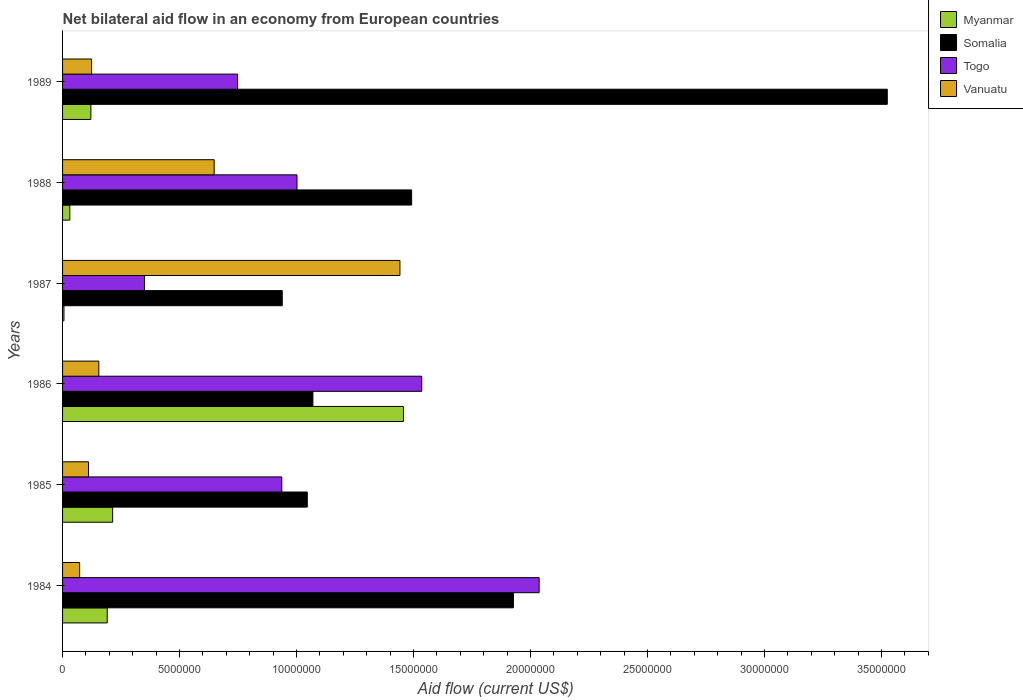How many different coloured bars are there?
Provide a succinct answer. 4. How many bars are there on the 1st tick from the top?
Your answer should be compact. 4. How many bars are there on the 5th tick from the bottom?
Your response must be concise. 4. In how many cases, is the number of bars for a given year not equal to the number of legend labels?
Keep it short and to the point. 0. What is the net bilateral aid flow in Myanmar in 1985?
Ensure brevity in your answer.  2.14e+06. Across all years, what is the maximum net bilateral aid flow in Vanuatu?
Keep it short and to the point. 1.44e+07. In which year was the net bilateral aid flow in Togo minimum?
Offer a terse response. 1987. What is the total net bilateral aid flow in Togo in the graph?
Give a very brief answer. 6.61e+07. What is the difference between the net bilateral aid flow in Vanuatu in 1985 and the net bilateral aid flow in Somalia in 1989?
Make the answer very short. -3.41e+07. What is the average net bilateral aid flow in Togo per year?
Provide a short and direct response. 1.10e+07. In how many years, is the net bilateral aid flow in Somalia greater than 17000000 US$?
Ensure brevity in your answer.  2. What is the ratio of the net bilateral aid flow in Togo in 1987 to that in 1989?
Keep it short and to the point. 0.47. Is the net bilateral aid flow in Togo in 1984 less than that in 1989?
Offer a very short reply. No. What is the difference between the highest and the second highest net bilateral aid flow in Myanmar?
Offer a terse response. 1.24e+07. What is the difference between the highest and the lowest net bilateral aid flow in Myanmar?
Your answer should be very brief. 1.45e+07. Is it the case that in every year, the sum of the net bilateral aid flow in Togo and net bilateral aid flow in Vanuatu is greater than the sum of net bilateral aid flow in Myanmar and net bilateral aid flow in Somalia?
Provide a short and direct response. No. What does the 2nd bar from the top in 1989 represents?
Provide a short and direct response. Togo. What does the 4th bar from the bottom in 1986 represents?
Provide a short and direct response. Vanuatu. Is it the case that in every year, the sum of the net bilateral aid flow in Vanuatu and net bilateral aid flow in Togo is greater than the net bilateral aid flow in Somalia?
Provide a short and direct response. No. How many bars are there?
Provide a short and direct response. 24. What is the difference between two consecutive major ticks on the X-axis?
Keep it short and to the point. 5.00e+06. Does the graph contain grids?
Your answer should be compact. No. Where does the legend appear in the graph?
Your answer should be very brief. Top right. What is the title of the graph?
Your answer should be compact. Net bilateral aid flow in an economy from European countries. Does "Mali" appear as one of the legend labels in the graph?
Give a very brief answer. No. What is the label or title of the Y-axis?
Ensure brevity in your answer.  Years. What is the Aid flow (current US$) of Myanmar in 1984?
Offer a terse response. 1.91e+06. What is the Aid flow (current US$) of Somalia in 1984?
Ensure brevity in your answer.  1.93e+07. What is the Aid flow (current US$) in Togo in 1984?
Your answer should be compact. 2.04e+07. What is the Aid flow (current US$) of Vanuatu in 1984?
Provide a succinct answer. 7.30e+05. What is the Aid flow (current US$) of Myanmar in 1985?
Make the answer very short. 2.14e+06. What is the Aid flow (current US$) of Somalia in 1985?
Provide a short and direct response. 1.05e+07. What is the Aid flow (current US$) of Togo in 1985?
Keep it short and to the point. 9.37e+06. What is the Aid flow (current US$) of Vanuatu in 1985?
Keep it short and to the point. 1.11e+06. What is the Aid flow (current US$) in Myanmar in 1986?
Offer a terse response. 1.46e+07. What is the Aid flow (current US$) in Somalia in 1986?
Your answer should be very brief. 1.07e+07. What is the Aid flow (current US$) in Togo in 1986?
Provide a succinct answer. 1.54e+07. What is the Aid flow (current US$) of Vanuatu in 1986?
Ensure brevity in your answer.  1.55e+06. What is the Aid flow (current US$) of Somalia in 1987?
Keep it short and to the point. 9.39e+06. What is the Aid flow (current US$) of Togo in 1987?
Provide a short and direct response. 3.50e+06. What is the Aid flow (current US$) in Vanuatu in 1987?
Make the answer very short. 1.44e+07. What is the Aid flow (current US$) in Somalia in 1988?
Your answer should be very brief. 1.49e+07. What is the Aid flow (current US$) in Togo in 1988?
Make the answer very short. 1.00e+07. What is the Aid flow (current US$) of Vanuatu in 1988?
Your answer should be compact. 6.48e+06. What is the Aid flow (current US$) of Myanmar in 1989?
Give a very brief answer. 1.21e+06. What is the Aid flow (current US$) of Somalia in 1989?
Offer a very short reply. 3.52e+07. What is the Aid flow (current US$) of Togo in 1989?
Give a very brief answer. 7.48e+06. What is the Aid flow (current US$) of Vanuatu in 1989?
Offer a terse response. 1.24e+06. Across all years, what is the maximum Aid flow (current US$) in Myanmar?
Offer a terse response. 1.46e+07. Across all years, what is the maximum Aid flow (current US$) of Somalia?
Offer a terse response. 3.52e+07. Across all years, what is the maximum Aid flow (current US$) of Togo?
Make the answer very short. 2.04e+07. Across all years, what is the maximum Aid flow (current US$) of Vanuatu?
Offer a very short reply. 1.44e+07. Across all years, what is the minimum Aid flow (current US$) of Myanmar?
Provide a short and direct response. 6.00e+04. Across all years, what is the minimum Aid flow (current US$) in Somalia?
Offer a terse response. 9.39e+06. Across all years, what is the minimum Aid flow (current US$) of Togo?
Give a very brief answer. 3.50e+06. Across all years, what is the minimum Aid flow (current US$) of Vanuatu?
Make the answer very short. 7.30e+05. What is the total Aid flow (current US$) in Myanmar in the graph?
Your response must be concise. 2.02e+07. What is the total Aid flow (current US$) in Somalia in the graph?
Offer a very short reply. 1.00e+08. What is the total Aid flow (current US$) of Togo in the graph?
Your answer should be very brief. 6.61e+07. What is the total Aid flow (current US$) of Vanuatu in the graph?
Make the answer very short. 2.55e+07. What is the difference between the Aid flow (current US$) of Somalia in 1984 and that in 1985?
Keep it short and to the point. 8.81e+06. What is the difference between the Aid flow (current US$) in Togo in 1984 and that in 1985?
Offer a terse response. 1.10e+07. What is the difference between the Aid flow (current US$) in Vanuatu in 1984 and that in 1985?
Offer a very short reply. -3.80e+05. What is the difference between the Aid flow (current US$) in Myanmar in 1984 and that in 1986?
Give a very brief answer. -1.27e+07. What is the difference between the Aid flow (current US$) in Somalia in 1984 and that in 1986?
Provide a succinct answer. 8.57e+06. What is the difference between the Aid flow (current US$) in Togo in 1984 and that in 1986?
Provide a short and direct response. 5.02e+06. What is the difference between the Aid flow (current US$) in Vanuatu in 1984 and that in 1986?
Your answer should be very brief. -8.20e+05. What is the difference between the Aid flow (current US$) in Myanmar in 1984 and that in 1987?
Offer a very short reply. 1.85e+06. What is the difference between the Aid flow (current US$) in Somalia in 1984 and that in 1987?
Offer a very short reply. 9.88e+06. What is the difference between the Aid flow (current US$) of Togo in 1984 and that in 1987?
Your answer should be very brief. 1.69e+07. What is the difference between the Aid flow (current US$) in Vanuatu in 1984 and that in 1987?
Keep it short and to the point. -1.37e+07. What is the difference between the Aid flow (current US$) of Myanmar in 1984 and that in 1988?
Keep it short and to the point. 1.60e+06. What is the difference between the Aid flow (current US$) in Somalia in 1984 and that in 1988?
Offer a terse response. 4.35e+06. What is the difference between the Aid flow (current US$) of Togo in 1984 and that in 1988?
Offer a terse response. 1.04e+07. What is the difference between the Aid flow (current US$) in Vanuatu in 1984 and that in 1988?
Make the answer very short. -5.75e+06. What is the difference between the Aid flow (current US$) in Myanmar in 1984 and that in 1989?
Provide a succinct answer. 7.00e+05. What is the difference between the Aid flow (current US$) of Somalia in 1984 and that in 1989?
Provide a short and direct response. -1.60e+07. What is the difference between the Aid flow (current US$) of Togo in 1984 and that in 1989?
Give a very brief answer. 1.29e+07. What is the difference between the Aid flow (current US$) of Vanuatu in 1984 and that in 1989?
Make the answer very short. -5.10e+05. What is the difference between the Aid flow (current US$) of Myanmar in 1985 and that in 1986?
Your response must be concise. -1.24e+07. What is the difference between the Aid flow (current US$) of Togo in 1985 and that in 1986?
Make the answer very short. -5.98e+06. What is the difference between the Aid flow (current US$) of Vanuatu in 1985 and that in 1986?
Make the answer very short. -4.40e+05. What is the difference between the Aid flow (current US$) in Myanmar in 1985 and that in 1987?
Your answer should be very brief. 2.08e+06. What is the difference between the Aid flow (current US$) of Somalia in 1985 and that in 1987?
Give a very brief answer. 1.07e+06. What is the difference between the Aid flow (current US$) of Togo in 1985 and that in 1987?
Provide a succinct answer. 5.87e+06. What is the difference between the Aid flow (current US$) of Vanuatu in 1985 and that in 1987?
Offer a terse response. -1.33e+07. What is the difference between the Aid flow (current US$) of Myanmar in 1985 and that in 1988?
Ensure brevity in your answer.  1.83e+06. What is the difference between the Aid flow (current US$) of Somalia in 1985 and that in 1988?
Your answer should be very brief. -4.46e+06. What is the difference between the Aid flow (current US$) in Togo in 1985 and that in 1988?
Your answer should be compact. -6.50e+05. What is the difference between the Aid flow (current US$) in Vanuatu in 1985 and that in 1988?
Make the answer very short. -5.37e+06. What is the difference between the Aid flow (current US$) of Myanmar in 1985 and that in 1989?
Offer a terse response. 9.30e+05. What is the difference between the Aid flow (current US$) in Somalia in 1985 and that in 1989?
Your response must be concise. -2.48e+07. What is the difference between the Aid flow (current US$) in Togo in 1985 and that in 1989?
Provide a succinct answer. 1.89e+06. What is the difference between the Aid flow (current US$) of Myanmar in 1986 and that in 1987?
Provide a short and direct response. 1.45e+07. What is the difference between the Aid flow (current US$) of Somalia in 1986 and that in 1987?
Your answer should be compact. 1.31e+06. What is the difference between the Aid flow (current US$) in Togo in 1986 and that in 1987?
Ensure brevity in your answer.  1.18e+07. What is the difference between the Aid flow (current US$) in Vanuatu in 1986 and that in 1987?
Provide a succinct answer. -1.29e+07. What is the difference between the Aid flow (current US$) of Myanmar in 1986 and that in 1988?
Keep it short and to the point. 1.43e+07. What is the difference between the Aid flow (current US$) of Somalia in 1986 and that in 1988?
Provide a succinct answer. -4.22e+06. What is the difference between the Aid flow (current US$) of Togo in 1986 and that in 1988?
Your response must be concise. 5.33e+06. What is the difference between the Aid flow (current US$) of Vanuatu in 1986 and that in 1988?
Offer a terse response. -4.93e+06. What is the difference between the Aid flow (current US$) of Myanmar in 1986 and that in 1989?
Offer a terse response. 1.34e+07. What is the difference between the Aid flow (current US$) in Somalia in 1986 and that in 1989?
Your response must be concise. -2.46e+07. What is the difference between the Aid flow (current US$) in Togo in 1986 and that in 1989?
Ensure brevity in your answer.  7.87e+06. What is the difference between the Aid flow (current US$) in Somalia in 1987 and that in 1988?
Make the answer very short. -5.53e+06. What is the difference between the Aid flow (current US$) of Togo in 1987 and that in 1988?
Provide a succinct answer. -6.52e+06. What is the difference between the Aid flow (current US$) in Vanuatu in 1987 and that in 1988?
Your answer should be very brief. 7.94e+06. What is the difference between the Aid flow (current US$) of Myanmar in 1987 and that in 1989?
Provide a short and direct response. -1.15e+06. What is the difference between the Aid flow (current US$) in Somalia in 1987 and that in 1989?
Your answer should be compact. -2.59e+07. What is the difference between the Aid flow (current US$) of Togo in 1987 and that in 1989?
Your answer should be compact. -3.98e+06. What is the difference between the Aid flow (current US$) in Vanuatu in 1987 and that in 1989?
Offer a very short reply. 1.32e+07. What is the difference between the Aid flow (current US$) in Myanmar in 1988 and that in 1989?
Give a very brief answer. -9.00e+05. What is the difference between the Aid flow (current US$) in Somalia in 1988 and that in 1989?
Offer a very short reply. -2.03e+07. What is the difference between the Aid flow (current US$) in Togo in 1988 and that in 1989?
Your response must be concise. 2.54e+06. What is the difference between the Aid flow (current US$) of Vanuatu in 1988 and that in 1989?
Make the answer very short. 5.24e+06. What is the difference between the Aid flow (current US$) in Myanmar in 1984 and the Aid flow (current US$) in Somalia in 1985?
Give a very brief answer. -8.55e+06. What is the difference between the Aid flow (current US$) in Myanmar in 1984 and the Aid flow (current US$) in Togo in 1985?
Your response must be concise. -7.46e+06. What is the difference between the Aid flow (current US$) of Myanmar in 1984 and the Aid flow (current US$) of Vanuatu in 1985?
Offer a very short reply. 8.00e+05. What is the difference between the Aid flow (current US$) of Somalia in 1984 and the Aid flow (current US$) of Togo in 1985?
Provide a succinct answer. 9.90e+06. What is the difference between the Aid flow (current US$) in Somalia in 1984 and the Aid flow (current US$) in Vanuatu in 1985?
Provide a succinct answer. 1.82e+07. What is the difference between the Aid flow (current US$) in Togo in 1984 and the Aid flow (current US$) in Vanuatu in 1985?
Provide a succinct answer. 1.93e+07. What is the difference between the Aid flow (current US$) of Myanmar in 1984 and the Aid flow (current US$) of Somalia in 1986?
Keep it short and to the point. -8.79e+06. What is the difference between the Aid flow (current US$) of Myanmar in 1984 and the Aid flow (current US$) of Togo in 1986?
Provide a short and direct response. -1.34e+07. What is the difference between the Aid flow (current US$) in Myanmar in 1984 and the Aid flow (current US$) in Vanuatu in 1986?
Ensure brevity in your answer.  3.60e+05. What is the difference between the Aid flow (current US$) of Somalia in 1984 and the Aid flow (current US$) of Togo in 1986?
Offer a very short reply. 3.92e+06. What is the difference between the Aid flow (current US$) in Somalia in 1984 and the Aid flow (current US$) in Vanuatu in 1986?
Provide a succinct answer. 1.77e+07. What is the difference between the Aid flow (current US$) in Togo in 1984 and the Aid flow (current US$) in Vanuatu in 1986?
Your answer should be compact. 1.88e+07. What is the difference between the Aid flow (current US$) of Myanmar in 1984 and the Aid flow (current US$) of Somalia in 1987?
Your response must be concise. -7.48e+06. What is the difference between the Aid flow (current US$) of Myanmar in 1984 and the Aid flow (current US$) of Togo in 1987?
Ensure brevity in your answer.  -1.59e+06. What is the difference between the Aid flow (current US$) in Myanmar in 1984 and the Aid flow (current US$) in Vanuatu in 1987?
Provide a short and direct response. -1.25e+07. What is the difference between the Aid flow (current US$) of Somalia in 1984 and the Aid flow (current US$) of Togo in 1987?
Keep it short and to the point. 1.58e+07. What is the difference between the Aid flow (current US$) of Somalia in 1984 and the Aid flow (current US$) of Vanuatu in 1987?
Provide a short and direct response. 4.85e+06. What is the difference between the Aid flow (current US$) of Togo in 1984 and the Aid flow (current US$) of Vanuatu in 1987?
Your answer should be compact. 5.95e+06. What is the difference between the Aid flow (current US$) in Myanmar in 1984 and the Aid flow (current US$) in Somalia in 1988?
Your answer should be compact. -1.30e+07. What is the difference between the Aid flow (current US$) in Myanmar in 1984 and the Aid flow (current US$) in Togo in 1988?
Your answer should be very brief. -8.11e+06. What is the difference between the Aid flow (current US$) in Myanmar in 1984 and the Aid flow (current US$) in Vanuatu in 1988?
Provide a short and direct response. -4.57e+06. What is the difference between the Aid flow (current US$) in Somalia in 1984 and the Aid flow (current US$) in Togo in 1988?
Offer a terse response. 9.25e+06. What is the difference between the Aid flow (current US$) in Somalia in 1984 and the Aid flow (current US$) in Vanuatu in 1988?
Your answer should be very brief. 1.28e+07. What is the difference between the Aid flow (current US$) of Togo in 1984 and the Aid flow (current US$) of Vanuatu in 1988?
Your answer should be very brief. 1.39e+07. What is the difference between the Aid flow (current US$) in Myanmar in 1984 and the Aid flow (current US$) in Somalia in 1989?
Your response must be concise. -3.33e+07. What is the difference between the Aid flow (current US$) of Myanmar in 1984 and the Aid flow (current US$) of Togo in 1989?
Offer a terse response. -5.57e+06. What is the difference between the Aid flow (current US$) in Myanmar in 1984 and the Aid flow (current US$) in Vanuatu in 1989?
Offer a terse response. 6.70e+05. What is the difference between the Aid flow (current US$) in Somalia in 1984 and the Aid flow (current US$) in Togo in 1989?
Your answer should be very brief. 1.18e+07. What is the difference between the Aid flow (current US$) in Somalia in 1984 and the Aid flow (current US$) in Vanuatu in 1989?
Ensure brevity in your answer.  1.80e+07. What is the difference between the Aid flow (current US$) of Togo in 1984 and the Aid flow (current US$) of Vanuatu in 1989?
Offer a terse response. 1.91e+07. What is the difference between the Aid flow (current US$) in Myanmar in 1985 and the Aid flow (current US$) in Somalia in 1986?
Your answer should be very brief. -8.56e+06. What is the difference between the Aid flow (current US$) in Myanmar in 1985 and the Aid flow (current US$) in Togo in 1986?
Provide a succinct answer. -1.32e+07. What is the difference between the Aid flow (current US$) in Myanmar in 1985 and the Aid flow (current US$) in Vanuatu in 1986?
Provide a succinct answer. 5.90e+05. What is the difference between the Aid flow (current US$) of Somalia in 1985 and the Aid flow (current US$) of Togo in 1986?
Provide a short and direct response. -4.89e+06. What is the difference between the Aid flow (current US$) of Somalia in 1985 and the Aid flow (current US$) of Vanuatu in 1986?
Provide a succinct answer. 8.91e+06. What is the difference between the Aid flow (current US$) of Togo in 1985 and the Aid flow (current US$) of Vanuatu in 1986?
Your response must be concise. 7.82e+06. What is the difference between the Aid flow (current US$) of Myanmar in 1985 and the Aid flow (current US$) of Somalia in 1987?
Offer a very short reply. -7.25e+06. What is the difference between the Aid flow (current US$) of Myanmar in 1985 and the Aid flow (current US$) of Togo in 1987?
Provide a succinct answer. -1.36e+06. What is the difference between the Aid flow (current US$) of Myanmar in 1985 and the Aid flow (current US$) of Vanuatu in 1987?
Offer a terse response. -1.23e+07. What is the difference between the Aid flow (current US$) of Somalia in 1985 and the Aid flow (current US$) of Togo in 1987?
Make the answer very short. 6.96e+06. What is the difference between the Aid flow (current US$) in Somalia in 1985 and the Aid flow (current US$) in Vanuatu in 1987?
Your answer should be compact. -3.96e+06. What is the difference between the Aid flow (current US$) in Togo in 1985 and the Aid flow (current US$) in Vanuatu in 1987?
Your answer should be compact. -5.05e+06. What is the difference between the Aid flow (current US$) of Myanmar in 1985 and the Aid flow (current US$) of Somalia in 1988?
Your answer should be compact. -1.28e+07. What is the difference between the Aid flow (current US$) of Myanmar in 1985 and the Aid flow (current US$) of Togo in 1988?
Provide a succinct answer. -7.88e+06. What is the difference between the Aid flow (current US$) of Myanmar in 1985 and the Aid flow (current US$) of Vanuatu in 1988?
Your answer should be very brief. -4.34e+06. What is the difference between the Aid flow (current US$) in Somalia in 1985 and the Aid flow (current US$) in Vanuatu in 1988?
Keep it short and to the point. 3.98e+06. What is the difference between the Aid flow (current US$) of Togo in 1985 and the Aid flow (current US$) of Vanuatu in 1988?
Ensure brevity in your answer.  2.89e+06. What is the difference between the Aid flow (current US$) of Myanmar in 1985 and the Aid flow (current US$) of Somalia in 1989?
Provide a succinct answer. -3.31e+07. What is the difference between the Aid flow (current US$) of Myanmar in 1985 and the Aid flow (current US$) of Togo in 1989?
Provide a succinct answer. -5.34e+06. What is the difference between the Aid flow (current US$) in Myanmar in 1985 and the Aid flow (current US$) in Vanuatu in 1989?
Ensure brevity in your answer.  9.00e+05. What is the difference between the Aid flow (current US$) in Somalia in 1985 and the Aid flow (current US$) in Togo in 1989?
Provide a short and direct response. 2.98e+06. What is the difference between the Aid flow (current US$) in Somalia in 1985 and the Aid flow (current US$) in Vanuatu in 1989?
Your answer should be very brief. 9.22e+06. What is the difference between the Aid flow (current US$) of Togo in 1985 and the Aid flow (current US$) of Vanuatu in 1989?
Give a very brief answer. 8.13e+06. What is the difference between the Aid flow (current US$) of Myanmar in 1986 and the Aid flow (current US$) of Somalia in 1987?
Your response must be concise. 5.18e+06. What is the difference between the Aid flow (current US$) in Myanmar in 1986 and the Aid flow (current US$) in Togo in 1987?
Give a very brief answer. 1.11e+07. What is the difference between the Aid flow (current US$) in Somalia in 1986 and the Aid flow (current US$) in Togo in 1987?
Ensure brevity in your answer.  7.20e+06. What is the difference between the Aid flow (current US$) of Somalia in 1986 and the Aid flow (current US$) of Vanuatu in 1987?
Provide a succinct answer. -3.72e+06. What is the difference between the Aid flow (current US$) of Togo in 1986 and the Aid flow (current US$) of Vanuatu in 1987?
Give a very brief answer. 9.30e+05. What is the difference between the Aid flow (current US$) of Myanmar in 1986 and the Aid flow (current US$) of Somalia in 1988?
Your response must be concise. -3.50e+05. What is the difference between the Aid flow (current US$) of Myanmar in 1986 and the Aid flow (current US$) of Togo in 1988?
Your response must be concise. 4.55e+06. What is the difference between the Aid flow (current US$) in Myanmar in 1986 and the Aid flow (current US$) in Vanuatu in 1988?
Ensure brevity in your answer.  8.09e+06. What is the difference between the Aid flow (current US$) in Somalia in 1986 and the Aid flow (current US$) in Togo in 1988?
Provide a short and direct response. 6.80e+05. What is the difference between the Aid flow (current US$) in Somalia in 1986 and the Aid flow (current US$) in Vanuatu in 1988?
Offer a very short reply. 4.22e+06. What is the difference between the Aid flow (current US$) in Togo in 1986 and the Aid flow (current US$) in Vanuatu in 1988?
Give a very brief answer. 8.87e+06. What is the difference between the Aid flow (current US$) of Myanmar in 1986 and the Aid flow (current US$) of Somalia in 1989?
Provide a short and direct response. -2.07e+07. What is the difference between the Aid flow (current US$) of Myanmar in 1986 and the Aid flow (current US$) of Togo in 1989?
Ensure brevity in your answer.  7.09e+06. What is the difference between the Aid flow (current US$) of Myanmar in 1986 and the Aid flow (current US$) of Vanuatu in 1989?
Your response must be concise. 1.33e+07. What is the difference between the Aid flow (current US$) in Somalia in 1986 and the Aid flow (current US$) in Togo in 1989?
Your answer should be very brief. 3.22e+06. What is the difference between the Aid flow (current US$) of Somalia in 1986 and the Aid flow (current US$) of Vanuatu in 1989?
Your answer should be compact. 9.46e+06. What is the difference between the Aid flow (current US$) in Togo in 1986 and the Aid flow (current US$) in Vanuatu in 1989?
Give a very brief answer. 1.41e+07. What is the difference between the Aid flow (current US$) in Myanmar in 1987 and the Aid flow (current US$) in Somalia in 1988?
Give a very brief answer. -1.49e+07. What is the difference between the Aid flow (current US$) in Myanmar in 1987 and the Aid flow (current US$) in Togo in 1988?
Provide a succinct answer. -9.96e+06. What is the difference between the Aid flow (current US$) in Myanmar in 1987 and the Aid flow (current US$) in Vanuatu in 1988?
Your answer should be compact. -6.42e+06. What is the difference between the Aid flow (current US$) of Somalia in 1987 and the Aid flow (current US$) of Togo in 1988?
Ensure brevity in your answer.  -6.30e+05. What is the difference between the Aid flow (current US$) of Somalia in 1987 and the Aid flow (current US$) of Vanuatu in 1988?
Provide a succinct answer. 2.91e+06. What is the difference between the Aid flow (current US$) in Togo in 1987 and the Aid flow (current US$) in Vanuatu in 1988?
Your response must be concise. -2.98e+06. What is the difference between the Aid flow (current US$) of Myanmar in 1987 and the Aid flow (current US$) of Somalia in 1989?
Ensure brevity in your answer.  -3.52e+07. What is the difference between the Aid flow (current US$) in Myanmar in 1987 and the Aid flow (current US$) in Togo in 1989?
Offer a terse response. -7.42e+06. What is the difference between the Aid flow (current US$) of Myanmar in 1987 and the Aid flow (current US$) of Vanuatu in 1989?
Make the answer very short. -1.18e+06. What is the difference between the Aid flow (current US$) of Somalia in 1987 and the Aid flow (current US$) of Togo in 1989?
Your answer should be compact. 1.91e+06. What is the difference between the Aid flow (current US$) of Somalia in 1987 and the Aid flow (current US$) of Vanuatu in 1989?
Offer a terse response. 8.15e+06. What is the difference between the Aid flow (current US$) of Togo in 1987 and the Aid flow (current US$) of Vanuatu in 1989?
Your answer should be very brief. 2.26e+06. What is the difference between the Aid flow (current US$) of Myanmar in 1988 and the Aid flow (current US$) of Somalia in 1989?
Offer a very short reply. -3.49e+07. What is the difference between the Aid flow (current US$) of Myanmar in 1988 and the Aid flow (current US$) of Togo in 1989?
Ensure brevity in your answer.  -7.17e+06. What is the difference between the Aid flow (current US$) of Myanmar in 1988 and the Aid flow (current US$) of Vanuatu in 1989?
Offer a terse response. -9.30e+05. What is the difference between the Aid flow (current US$) of Somalia in 1988 and the Aid flow (current US$) of Togo in 1989?
Your answer should be compact. 7.44e+06. What is the difference between the Aid flow (current US$) in Somalia in 1988 and the Aid flow (current US$) in Vanuatu in 1989?
Your answer should be compact. 1.37e+07. What is the difference between the Aid flow (current US$) of Togo in 1988 and the Aid flow (current US$) of Vanuatu in 1989?
Your answer should be very brief. 8.78e+06. What is the average Aid flow (current US$) in Myanmar per year?
Your answer should be compact. 3.37e+06. What is the average Aid flow (current US$) in Somalia per year?
Offer a very short reply. 1.67e+07. What is the average Aid flow (current US$) of Togo per year?
Offer a very short reply. 1.10e+07. What is the average Aid flow (current US$) in Vanuatu per year?
Offer a terse response. 4.26e+06. In the year 1984, what is the difference between the Aid flow (current US$) of Myanmar and Aid flow (current US$) of Somalia?
Offer a terse response. -1.74e+07. In the year 1984, what is the difference between the Aid flow (current US$) of Myanmar and Aid flow (current US$) of Togo?
Ensure brevity in your answer.  -1.85e+07. In the year 1984, what is the difference between the Aid flow (current US$) of Myanmar and Aid flow (current US$) of Vanuatu?
Offer a terse response. 1.18e+06. In the year 1984, what is the difference between the Aid flow (current US$) of Somalia and Aid flow (current US$) of Togo?
Your response must be concise. -1.10e+06. In the year 1984, what is the difference between the Aid flow (current US$) of Somalia and Aid flow (current US$) of Vanuatu?
Your answer should be compact. 1.85e+07. In the year 1984, what is the difference between the Aid flow (current US$) of Togo and Aid flow (current US$) of Vanuatu?
Offer a terse response. 1.96e+07. In the year 1985, what is the difference between the Aid flow (current US$) of Myanmar and Aid flow (current US$) of Somalia?
Offer a very short reply. -8.32e+06. In the year 1985, what is the difference between the Aid flow (current US$) in Myanmar and Aid flow (current US$) in Togo?
Your response must be concise. -7.23e+06. In the year 1985, what is the difference between the Aid flow (current US$) in Myanmar and Aid flow (current US$) in Vanuatu?
Make the answer very short. 1.03e+06. In the year 1985, what is the difference between the Aid flow (current US$) of Somalia and Aid flow (current US$) of Togo?
Your answer should be very brief. 1.09e+06. In the year 1985, what is the difference between the Aid flow (current US$) in Somalia and Aid flow (current US$) in Vanuatu?
Make the answer very short. 9.35e+06. In the year 1985, what is the difference between the Aid flow (current US$) in Togo and Aid flow (current US$) in Vanuatu?
Provide a succinct answer. 8.26e+06. In the year 1986, what is the difference between the Aid flow (current US$) of Myanmar and Aid flow (current US$) of Somalia?
Your response must be concise. 3.87e+06. In the year 1986, what is the difference between the Aid flow (current US$) of Myanmar and Aid flow (current US$) of Togo?
Your response must be concise. -7.80e+05. In the year 1986, what is the difference between the Aid flow (current US$) in Myanmar and Aid flow (current US$) in Vanuatu?
Your answer should be compact. 1.30e+07. In the year 1986, what is the difference between the Aid flow (current US$) in Somalia and Aid flow (current US$) in Togo?
Provide a succinct answer. -4.65e+06. In the year 1986, what is the difference between the Aid flow (current US$) of Somalia and Aid flow (current US$) of Vanuatu?
Offer a terse response. 9.15e+06. In the year 1986, what is the difference between the Aid flow (current US$) of Togo and Aid flow (current US$) of Vanuatu?
Offer a very short reply. 1.38e+07. In the year 1987, what is the difference between the Aid flow (current US$) in Myanmar and Aid flow (current US$) in Somalia?
Give a very brief answer. -9.33e+06. In the year 1987, what is the difference between the Aid flow (current US$) of Myanmar and Aid flow (current US$) of Togo?
Provide a succinct answer. -3.44e+06. In the year 1987, what is the difference between the Aid flow (current US$) in Myanmar and Aid flow (current US$) in Vanuatu?
Offer a very short reply. -1.44e+07. In the year 1987, what is the difference between the Aid flow (current US$) of Somalia and Aid flow (current US$) of Togo?
Your answer should be compact. 5.89e+06. In the year 1987, what is the difference between the Aid flow (current US$) of Somalia and Aid flow (current US$) of Vanuatu?
Provide a short and direct response. -5.03e+06. In the year 1987, what is the difference between the Aid flow (current US$) in Togo and Aid flow (current US$) in Vanuatu?
Ensure brevity in your answer.  -1.09e+07. In the year 1988, what is the difference between the Aid flow (current US$) of Myanmar and Aid flow (current US$) of Somalia?
Provide a succinct answer. -1.46e+07. In the year 1988, what is the difference between the Aid flow (current US$) in Myanmar and Aid flow (current US$) in Togo?
Provide a succinct answer. -9.71e+06. In the year 1988, what is the difference between the Aid flow (current US$) of Myanmar and Aid flow (current US$) of Vanuatu?
Offer a terse response. -6.17e+06. In the year 1988, what is the difference between the Aid flow (current US$) in Somalia and Aid flow (current US$) in Togo?
Offer a very short reply. 4.90e+06. In the year 1988, what is the difference between the Aid flow (current US$) of Somalia and Aid flow (current US$) of Vanuatu?
Make the answer very short. 8.44e+06. In the year 1988, what is the difference between the Aid flow (current US$) of Togo and Aid flow (current US$) of Vanuatu?
Your answer should be compact. 3.54e+06. In the year 1989, what is the difference between the Aid flow (current US$) of Myanmar and Aid flow (current US$) of Somalia?
Ensure brevity in your answer.  -3.40e+07. In the year 1989, what is the difference between the Aid flow (current US$) of Myanmar and Aid flow (current US$) of Togo?
Provide a short and direct response. -6.27e+06. In the year 1989, what is the difference between the Aid flow (current US$) of Somalia and Aid flow (current US$) of Togo?
Give a very brief answer. 2.78e+07. In the year 1989, what is the difference between the Aid flow (current US$) of Somalia and Aid flow (current US$) of Vanuatu?
Make the answer very short. 3.40e+07. In the year 1989, what is the difference between the Aid flow (current US$) of Togo and Aid flow (current US$) of Vanuatu?
Your answer should be compact. 6.24e+06. What is the ratio of the Aid flow (current US$) of Myanmar in 1984 to that in 1985?
Offer a very short reply. 0.89. What is the ratio of the Aid flow (current US$) in Somalia in 1984 to that in 1985?
Your response must be concise. 1.84. What is the ratio of the Aid flow (current US$) of Togo in 1984 to that in 1985?
Give a very brief answer. 2.17. What is the ratio of the Aid flow (current US$) in Vanuatu in 1984 to that in 1985?
Provide a succinct answer. 0.66. What is the ratio of the Aid flow (current US$) in Myanmar in 1984 to that in 1986?
Provide a succinct answer. 0.13. What is the ratio of the Aid flow (current US$) in Somalia in 1984 to that in 1986?
Offer a terse response. 1.8. What is the ratio of the Aid flow (current US$) of Togo in 1984 to that in 1986?
Offer a very short reply. 1.33. What is the ratio of the Aid flow (current US$) of Vanuatu in 1984 to that in 1986?
Offer a very short reply. 0.47. What is the ratio of the Aid flow (current US$) in Myanmar in 1984 to that in 1987?
Keep it short and to the point. 31.83. What is the ratio of the Aid flow (current US$) of Somalia in 1984 to that in 1987?
Your answer should be very brief. 2.05. What is the ratio of the Aid flow (current US$) of Togo in 1984 to that in 1987?
Give a very brief answer. 5.82. What is the ratio of the Aid flow (current US$) in Vanuatu in 1984 to that in 1987?
Your answer should be very brief. 0.05. What is the ratio of the Aid flow (current US$) in Myanmar in 1984 to that in 1988?
Your response must be concise. 6.16. What is the ratio of the Aid flow (current US$) of Somalia in 1984 to that in 1988?
Keep it short and to the point. 1.29. What is the ratio of the Aid flow (current US$) in Togo in 1984 to that in 1988?
Your answer should be compact. 2.03. What is the ratio of the Aid flow (current US$) in Vanuatu in 1984 to that in 1988?
Keep it short and to the point. 0.11. What is the ratio of the Aid flow (current US$) in Myanmar in 1984 to that in 1989?
Give a very brief answer. 1.58. What is the ratio of the Aid flow (current US$) in Somalia in 1984 to that in 1989?
Provide a short and direct response. 0.55. What is the ratio of the Aid flow (current US$) in Togo in 1984 to that in 1989?
Offer a terse response. 2.72. What is the ratio of the Aid flow (current US$) of Vanuatu in 1984 to that in 1989?
Make the answer very short. 0.59. What is the ratio of the Aid flow (current US$) in Myanmar in 1985 to that in 1986?
Your response must be concise. 0.15. What is the ratio of the Aid flow (current US$) in Somalia in 1985 to that in 1986?
Your answer should be very brief. 0.98. What is the ratio of the Aid flow (current US$) in Togo in 1985 to that in 1986?
Keep it short and to the point. 0.61. What is the ratio of the Aid flow (current US$) in Vanuatu in 1985 to that in 1986?
Offer a terse response. 0.72. What is the ratio of the Aid flow (current US$) of Myanmar in 1985 to that in 1987?
Your response must be concise. 35.67. What is the ratio of the Aid flow (current US$) of Somalia in 1985 to that in 1987?
Your response must be concise. 1.11. What is the ratio of the Aid flow (current US$) of Togo in 1985 to that in 1987?
Your answer should be very brief. 2.68. What is the ratio of the Aid flow (current US$) of Vanuatu in 1985 to that in 1987?
Provide a succinct answer. 0.08. What is the ratio of the Aid flow (current US$) of Myanmar in 1985 to that in 1988?
Make the answer very short. 6.9. What is the ratio of the Aid flow (current US$) of Somalia in 1985 to that in 1988?
Keep it short and to the point. 0.7. What is the ratio of the Aid flow (current US$) in Togo in 1985 to that in 1988?
Make the answer very short. 0.94. What is the ratio of the Aid flow (current US$) of Vanuatu in 1985 to that in 1988?
Your answer should be compact. 0.17. What is the ratio of the Aid flow (current US$) in Myanmar in 1985 to that in 1989?
Keep it short and to the point. 1.77. What is the ratio of the Aid flow (current US$) in Somalia in 1985 to that in 1989?
Your answer should be very brief. 0.3. What is the ratio of the Aid flow (current US$) in Togo in 1985 to that in 1989?
Keep it short and to the point. 1.25. What is the ratio of the Aid flow (current US$) of Vanuatu in 1985 to that in 1989?
Your answer should be very brief. 0.9. What is the ratio of the Aid flow (current US$) of Myanmar in 1986 to that in 1987?
Your answer should be very brief. 242.83. What is the ratio of the Aid flow (current US$) in Somalia in 1986 to that in 1987?
Provide a short and direct response. 1.14. What is the ratio of the Aid flow (current US$) of Togo in 1986 to that in 1987?
Your response must be concise. 4.39. What is the ratio of the Aid flow (current US$) of Vanuatu in 1986 to that in 1987?
Offer a very short reply. 0.11. What is the ratio of the Aid flow (current US$) in Myanmar in 1986 to that in 1988?
Keep it short and to the point. 47. What is the ratio of the Aid flow (current US$) of Somalia in 1986 to that in 1988?
Your answer should be compact. 0.72. What is the ratio of the Aid flow (current US$) in Togo in 1986 to that in 1988?
Provide a succinct answer. 1.53. What is the ratio of the Aid flow (current US$) in Vanuatu in 1986 to that in 1988?
Give a very brief answer. 0.24. What is the ratio of the Aid flow (current US$) of Myanmar in 1986 to that in 1989?
Keep it short and to the point. 12.04. What is the ratio of the Aid flow (current US$) in Somalia in 1986 to that in 1989?
Offer a terse response. 0.3. What is the ratio of the Aid flow (current US$) of Togo in 1986 to that in 1989?
Your answer should be very brief. 2.05. What is the ratio of the Aid flow (current US$) of Vanuatu in 1986 to that in 1989?
Keep it short and to the point. 1.25. What is the ratio of the Aid flow (current US$) of Myanmar in 1987 to that in 1988?
Provide a succinct answer. 0.19. What is the ratio of the Aid flow (current US$) of Somalia in 1987 to that in 1988?
Your answer should be compact. 0.63. What is the ratio of the Aid flow (current US$) of Togo in 1987 to that in 1988?
Your response must be concise. 0.35. What is the ratio of the Aid flow (current US$) in Vanuatu in 1987 to that in 1988?
Provide a succinct answer. 2.23. What is the ratio of the Aid flow (current US$) of Myanmar in 1987 to that in 1989?
Keep it short and to the point. 0.05. What is the ratio of the Aid flow (current US$) of Somalia in 1987 to that in 1989?
Make the answer very short. 0.27. What is the ratio of the Aid flow (current US$) of Togo in 1987 to that in 1989?
Make the answer very short. 0.47. What is the ratio of the Aid flow (current US$) of Vanuatu in 1987 to that in 1989?
Ensure brevity in your answer.  11.63. What is the ratio of the Aid flow (current US$) in Myanmar in 1988 to that in 1989?
Provide a short and direct response. 0.26. What is the ratio of the Aid flow (current US$) of Somalia in 1988 to that in 1989?
Provide a succinct answer. 0.42. What is the ratio of the Aid flow (current US$) of Togo in 1988 to that in 1989?
Offer a very short reply. 1.34. What is the ratio of the Aid flow (current US$) in Vanuatu in 1988 to that in 1989?
Provide a short and direct response. 5.23. What is the difference between the highest and the second highest Aid flow (current US$) in Myanmar?
Keep it short and to the point. 1.24e+07. What is the difference between the highest and the second highest Aid flow (current US$) of Somalia?
Provide a short and direct response. 1.60e+07. What is the difference between the highest and the second highest Aid flow (current US$) of Togo?
Ensure brevity in your answer.  5.02e+06. What is the difference between the highest and the second highest Aid flow (current US$) of Vanuatu?
Keep it short and to the point. 7.94e+06. What is the difference between the highest and the lowest Aid flow (current US$) of Myanmar?
Provide a succinct answer. 1.45e+07. What is the difference between the highest and the lowest Aid flow (current US$) of Somalia?
Keep it short and to the point. 2.59e+07. What is the difference between the highest and the lowest Aid flow (current US$) of Togo?
Give a very brief answer. 1.69e+07. What is the difference between the highest and the lowest Aid flow (current US$) of Vanuatu?
Keep it short and to the point. 1.37e+07. 